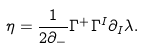Convert formula to latex. <formula><loc_0><loc_0><loc_500><loc_500>\eta = \frac { 1 } { 2 \partial _ { - } } \Gamma ^ { + } \Gamma ^ { I } \partial _ { I } \lambda .</formula> 